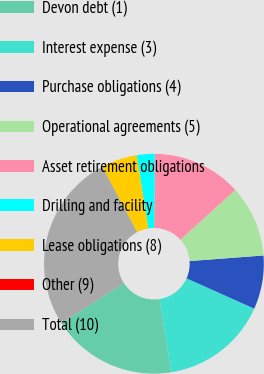Convert chart. <chart><loc_0><loc_0><loc_500><loc_500><pie_chart><fcel>Devon debt (1)<fcel>Interest expense (3)<fcel>Purchase obligations (4)<fcel>Operational agreements (5)<fcel>Asset retirement obligations<fcel>Drilling and facility<fcel>Lease obligations (8)<fcel>Other (9)<fcel>Total (10)<nl><fcel>18.41%<fcel>15.79%<fcel>7.9%<fcel>10.53%<fcel>13.16%<fcel>2.64%<fcel>5.27%<fcel>0.01%<fcel>26.3%<nl></chart> 